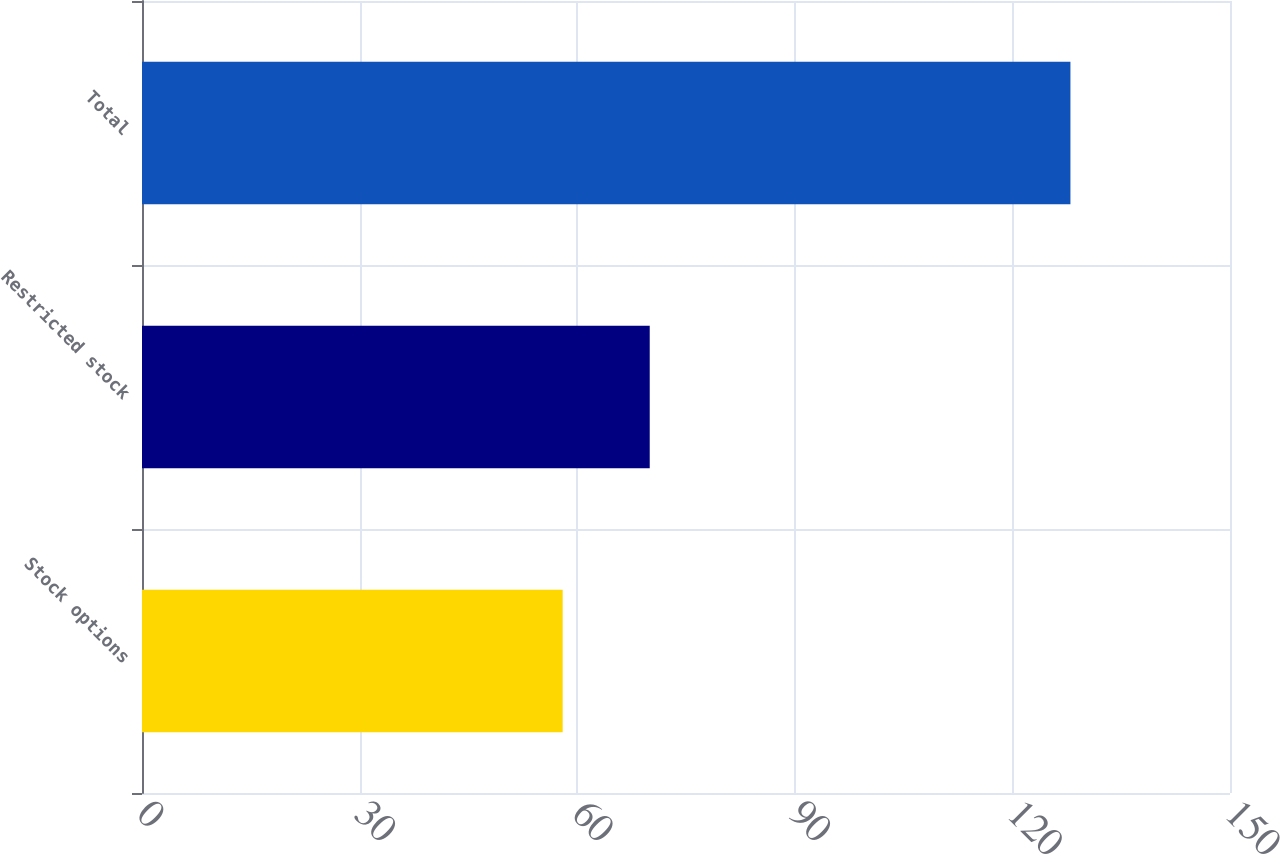Convert chart. <chart><loc_0><loc_0><loc_500><loc_500><bar_chart><fcel>Stock options<fcel>Restricted stock<fcel>Total<nl><fcel>58<fcel>70<fcel>128<nl></chart> 